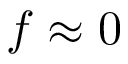Convert formula to latex. <formula><loc_0><loc_0><loc_500><loc_500>f \approx 0</formula> 